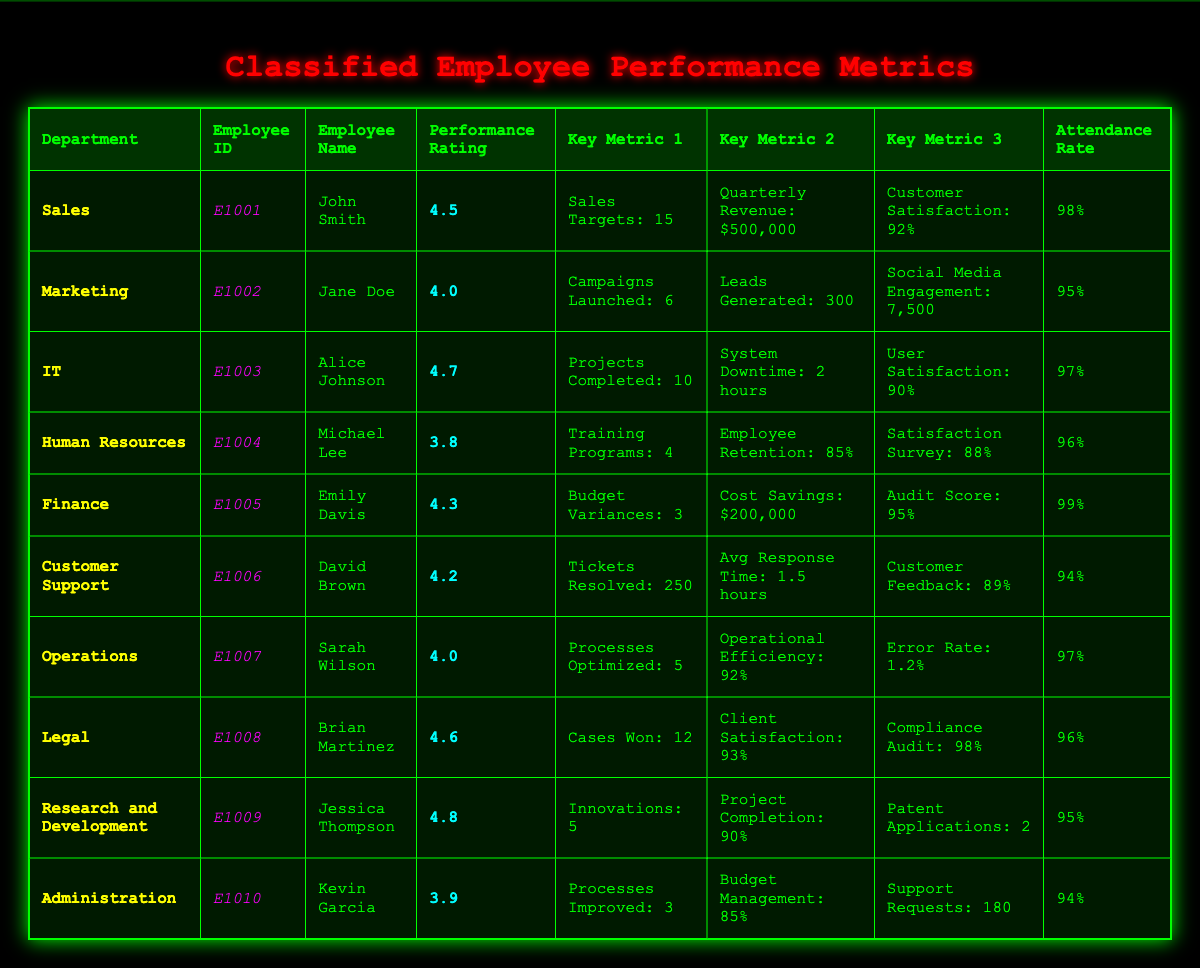What is the Performance Rating of the employee from the IT department? The IT department employee is Alice Johnson, whose Performance Rating is stated in the table.
Answer: 4.7 Which employee achieved the highest Performance Rating? By comparing the Performance Ratings in the table, Jessica Thompson from Research and Development has the highest at 4.8.
Answer: 4.8 What is the average Attendance Rate for the employees listed in the table? The Attendance Rates are 98%, 95%, 97%, 96%, 99%, 94%, 97%, 96%, 95%, and 94%. Adding them gives  98 + 95 + 97 + 96 + 99 + 94 + 97 + 96 + 95 + 94 =  95.5 (divided by 10 employees).
Answer: 95.5% Did any employee from the Human Resources department have a Performance Rating above 4.0? The Performance Rating for Michael Lee in Human Resources is 3.8, which is below 4.0. Thus, the answer is no.
Answer: No Which department had the most number of key metrics listed? In the table, each employee has four key metrics listed, thus every department has the same number of metrics, which is four.
Answer: Four Who has the lowest Customer Satisfaction Score, and what is it? Looking at the Customer Satisfaction Scores, David Brown from Customer Support has the lowest score at 89%.
Answer: 89% What is the difference in Attendance Rates between the employee with the highest and lowest Attendance Rate? Emily Davis has the highest Attendance Rate at 99%, while customer support David Brown has 94%. The difference is 99 - 94 = 5%.
Answer: 5% Is the average response time for Customer Support representative above or below 1.5 hours? The Average Response Time for David Brown in Customer Support is stated as 1.5 hours, therefore it is equal.
Answer: Equal Which department has the highest Cost Savings identified? According to the table, Emily Davis from Finance identified $200,000 in Cost Savings, which is the highest compared to other departments.
Answer: Finance What is the total number of tickets resolved by the Customer Support employee and how does it compare with the number of campaigns launched in Marketing? David Brown resolved 250 tickets, while Jane Doe launched 6 campaigns. The comparison indicates that 250 is vastly larger than 6.
Answer: 250 tickets resolved, 6 campaigns launched (250 > 6) 